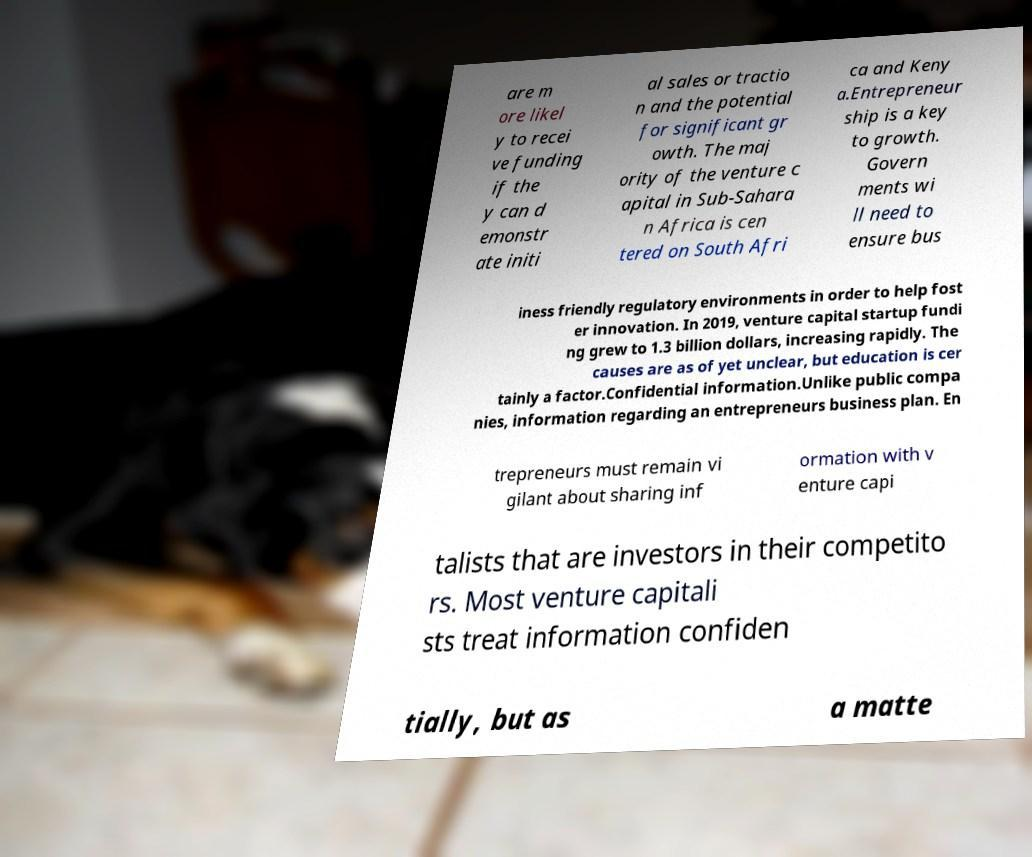Please identify and transcribe the text found in this image. are m ore likel y to recei ve funding if the y can d emonstr ate initi al sales or tractio n and the potential for significant gr owth. The maj ority of the venture c apital in Sub-Sahara n Africa is cen tered on South Afri ca and Keny a.Entrepreneur ship is a key to growth. Govern ments wi ll need to ensure bus iness friendly regulatory environments in order to help fost er innovation. In 2019, venture capital startup fundi ng grew to 1.3 billion dollars, increasing rapidly. The causes are as of yet unclear, but education is cer tainly a factor.Confidential information.Unlike public compa nies, information regarding an entrepreneurs business plan. En trepreneurs must remain vi gilant about sharing inf ormation with v enture capi talists that are investors in their competito rs. Most venture capitali sts treat information confiden tially, but as a matte 